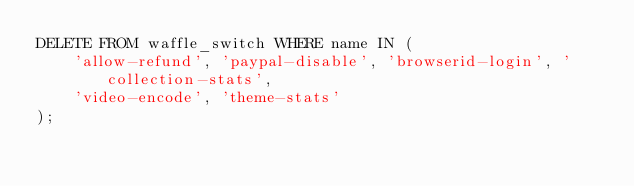Convert code to text. <code><loc_0><loc_0><loc_500><loc_500><_SQL_>DELETE FROM waffle_switch WHERE name IN (
    'allow-refund', 'paypal-disable', 'browserid-login', 'collection-stats',
    'video-encode', 'theme-stats'
);
</code> 